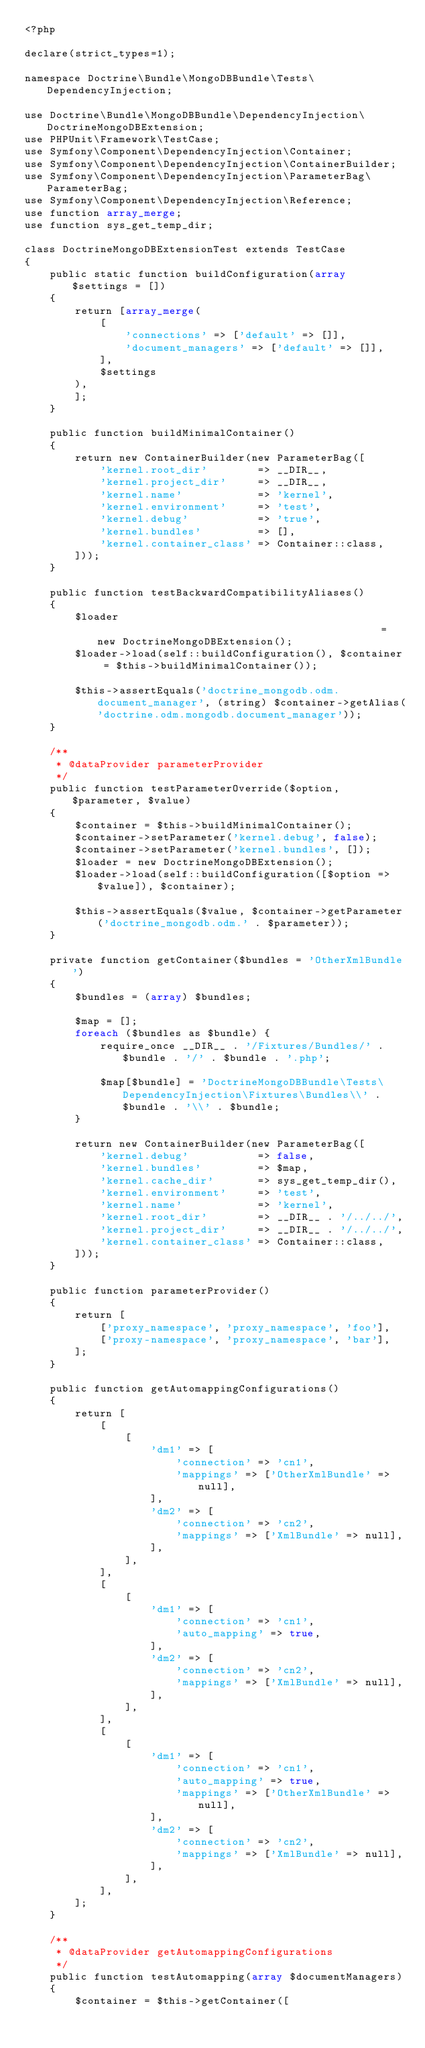<code> <loc_0><loc_0><loc_500><loc_500><_PHP_><?php

declare(strict_types=1);

namespace Doctrine\Bundle\MongoDBBundle\Tests\DependencyInjection;

use Doctrine\Bundle\MongoDBBundle\DependencyInjection\DoctrineMongoDBExtension;
use PHPUnit\Framework\TestCase;
use Symfony\Component\DependencyInjection\Container;
use Symfony\Component\DependencyInjection\ContainerBuilder;
use Symfony\Component\DependencyInjection\ParameterBag\ParameterBag;
use Symfony\Component\DependencyInjection\Reference;
use function array_merge;
use function sys_get_temp_dir;

class DoctrineMongoDBExtensionTest extends TestCase
{
    public static function buildConfiguration(array $settings = [])
    {
        return [array_merge(
            [
                'connections' => ['default' => []],
                'document_managers' => ['default' => []],
            ],
            $settings
        ),
        ];
    }

    public function buildMinimalContainer()
    {
        return new ContainerBuilder(new ParameterBag([
            'kernel.root_dir'        => __DIR__,
            'kernel.project_dir'     => __DIR__,
            'kernel.name'            => 'kernel',
            'kernel.environment'     => 'test',
            'kernel.debug'           => 'true',
            'kernel.bundles'         => [],
            'kernel.container_class' => Container::class,
        ]));
    }

    public function testBackwardCompatibilityAliases()
    {
        $loader                                              = new DoctrineMongoDBExtension();
        $loader->load(self::buildConfiguration(), $container = $this->buildMinimalContainer());

        $this->assertEquals('doctrine_mongodb.odm.document_manager', (string) $container->getAlias('doctrine.odm.mongodb.document_manager'));
    }

    /**
     * @dataProvider parameterProvider
     */
    public function testParameterOverride($option, $parameter, $value)
    {
        $container = $this->buildMinimalContainer();
        $container->setParameter('kernel.debug', false);
        $container->setParameter('kernel.bundles', []);
        $loader = new DoctrineMongoDBExtension();
        $loader->load(self::buildConfiguration([$option => $value]), $container);

        $this->assertEquals($value, $container->getParameter('doctrine_mongodb.odm.' . $parameter));
    }

    private function getContainer($bundles = 'OtherXmlBundle')
    {
        $bundles = (array) $bundles;

        $map = [];
        foreach ($bundles as $bundle) {
            require_once __DIR__ . '/Fixtures/Bundles/' . $bundle . '/' . $bundle . '.php';

            $map[$bundle] = 'DoctrineMongoDBBundle\Tests\DependencyInjection\Fixtures\Bundles\\' . $bundle . '\\' . $bundle;
        }

        return new ContainerBuilder(new ParameterBag([
            'kernel.debug'           => false,
            'kernel.bundles'         => $map,
            'kernel.cache_dir'       => sys_get_temp_dir(),
            'kernel.environment'     => 'test',
            'kernel.name'            => 'kernel',
            'kernel.root_dir'        => __DIR__ . '/../../',
            'kernel.project_dir'     => __DIR__ . '/../../',
            'kernel.container_class' => Container::class,
        ]));
    }

    public function parameterProvider()
    {
        return [
            ['proxy_namespace', 'proxy_namespace', 'foo'],
            ['proxy-namespace', 'proxy_namespace', 'bar'],
        ];
    }

    public function getAutomappingConfigurations()
    {
        return [
            [
                [
                    'dm1' => [
                        'connection' => 'cn1',
                        'mappings' => ['OtherXmlBundle' => null],
                    ],
                    'dm2' => [
                        'connection' => 'cn2',
                        'mappings' => ['XmlBundle' => null],
                    ],
                ],
            ],
            [
                [
                    'dm1' => [
                        'connection' => 'cn1',
                        'auto_mapping' => true,
                    ],
                    'dm2' => [
                        'connection' => 'cn2',
                        'mappings' => ['XmlBundle' => null],
                    ],
                ],
            ],
            [
                [
                    'dm1' => [
                        'connection' => 'cn1',
                        'auto_mapping' => true,
                        'mappings' => ['OtherXmlBundle' => null],
                    ],
                    'dm2' => [
                        'connection' => 'cn2',
                        'mappings' => ['XmlBundle' => null],
                    ],
                ],
            ],
        ];
    }

    /**
     * @dataProvider getAutomappingConfigurations
     */
    public function testAutomapping(array $documentManagers)
    {
        $container = $this->getContainer([</code> 